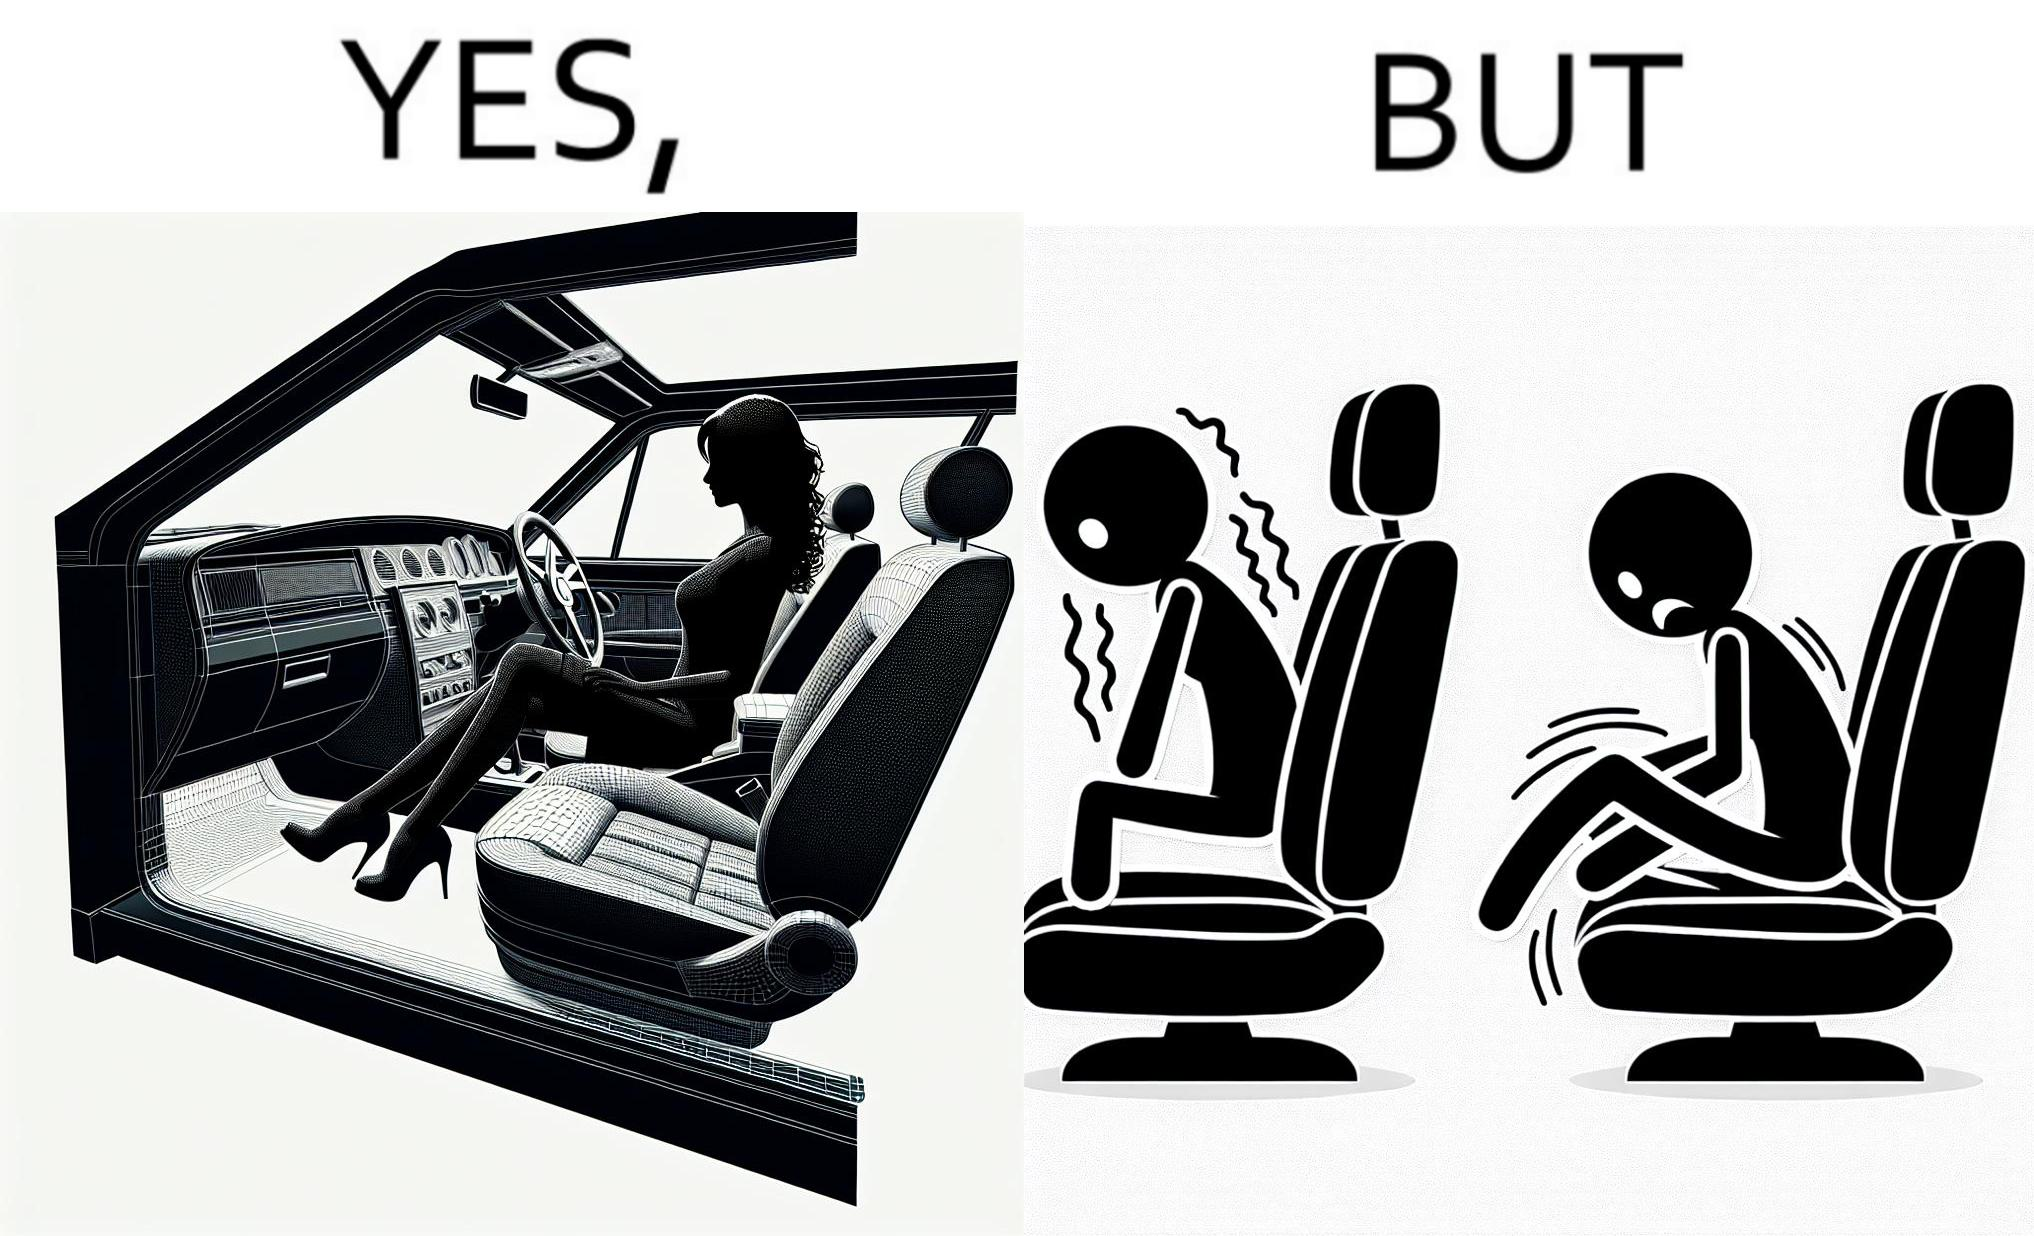Explain the humor or irony in this image. The image is ironic, because the woman is wearing a short dress to look stylish but she had to face inconvenience while travelling in car due to her short dress only. 